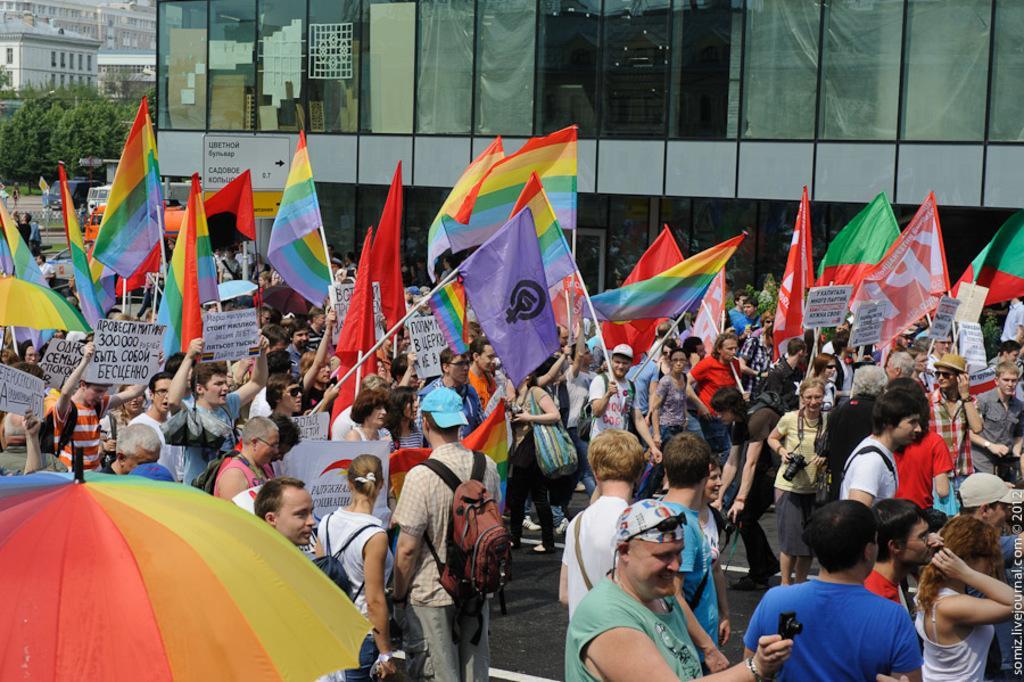Describe this image in one or two sentences. In this image we can see there are few people walking on the road, in them, some are holding flags and some are holding posters with some text. In the background there are buildings and trees. 